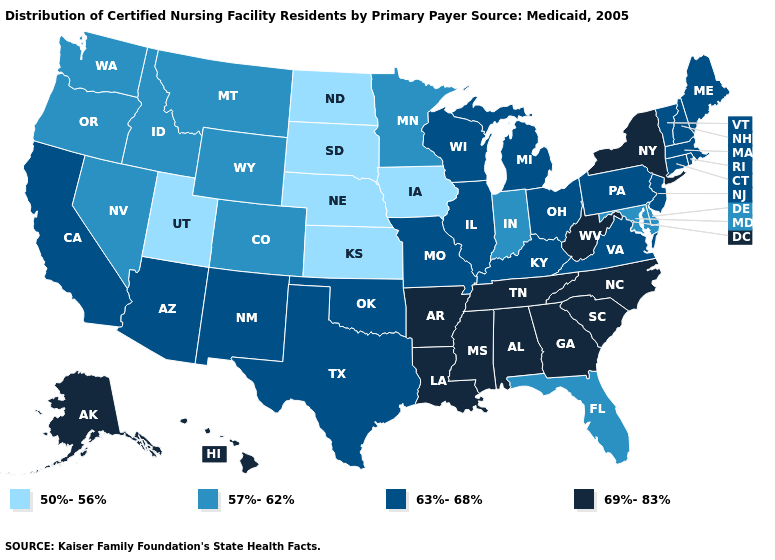How many symbols are there in the legend?
Keep it brief. 4. What is the highest value in the South ?
Answer briefly. 69%-83%. What is the lowest value in the USA?
Give a very brief answer. 50%-56%. Which states have the lowest value in the Northeast?
Answer briefly. Connecticut, Maine, Massachusetts, New Hampshire, New Jersey, Pennsylvania, Rhode Island, Vermont. Does Hawaii have the lowest value in the USA?
Concise answer only. No. What is the value of Oklahoma?
Concise answer only. 63%-68%. Among the states that border Kansas , which have the lowest value?
Keep it brief. Nebraska. What is the value of Rhode Island?
Concise answer only. 63%-68%. How many symbols are there in the legend?
Concise answer only. 4. What is the value of Wyoming?
Concise answer only. 57%-62%. What is the value of Connecticut?
Keep it brief. 63%-68%. Name the states that have a value in the range 69%-83%?
Short answer required. Alabama, Alaska, Arkansas, Georgia, Hawaii, Louisiana, Mississippi, New York, North Carolina, South Carolina, Tennessee, West Virginia. Does Washington have the highest value in the USA?
Short answer required. No. Does Michigan have the same value as Rhode Island?
Quick response, please. Yes. What is the value of New Jersey?
Give a very brief answer. 63%-68%. 